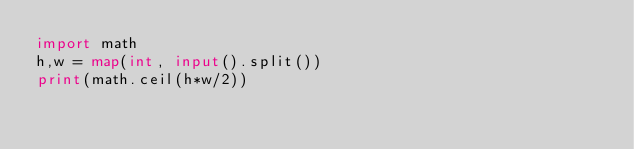Convert code to text. <code><loc_0><loc_0><loc_500><loc_500><_Python_>import math
h,w = map(int, input().split())
print(math.ceil(h*w/2))</code> 